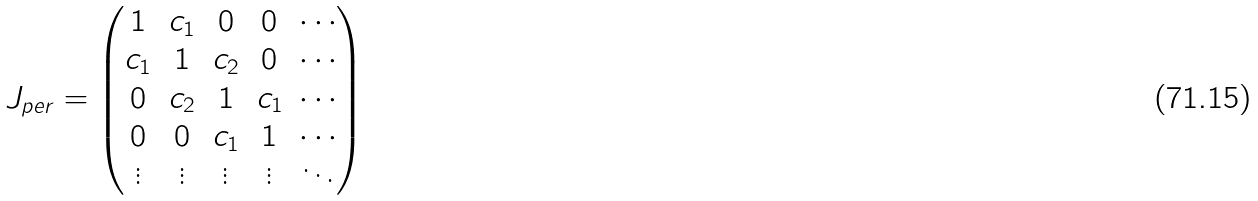Convert formula to latex. <formula><loc_0><loc_0><loc_500><loc_500>J _ { p e r } = \begin{pmatrix} 1 & c _ { 1 } & 0 & 0 & \cdots \\ c _ { 1 } & 1 & c _ { 2 } & 0 & \cdots \\ 0 & c _ { 2 } & 1 & c _ { 1 } & \cdots \\ 0 & 0 & c _ { 1 } & 1 & \cdots \\ \vdots & \vdots & \vdots & \vdots & \ddots \end{pmatrix}</formula> 